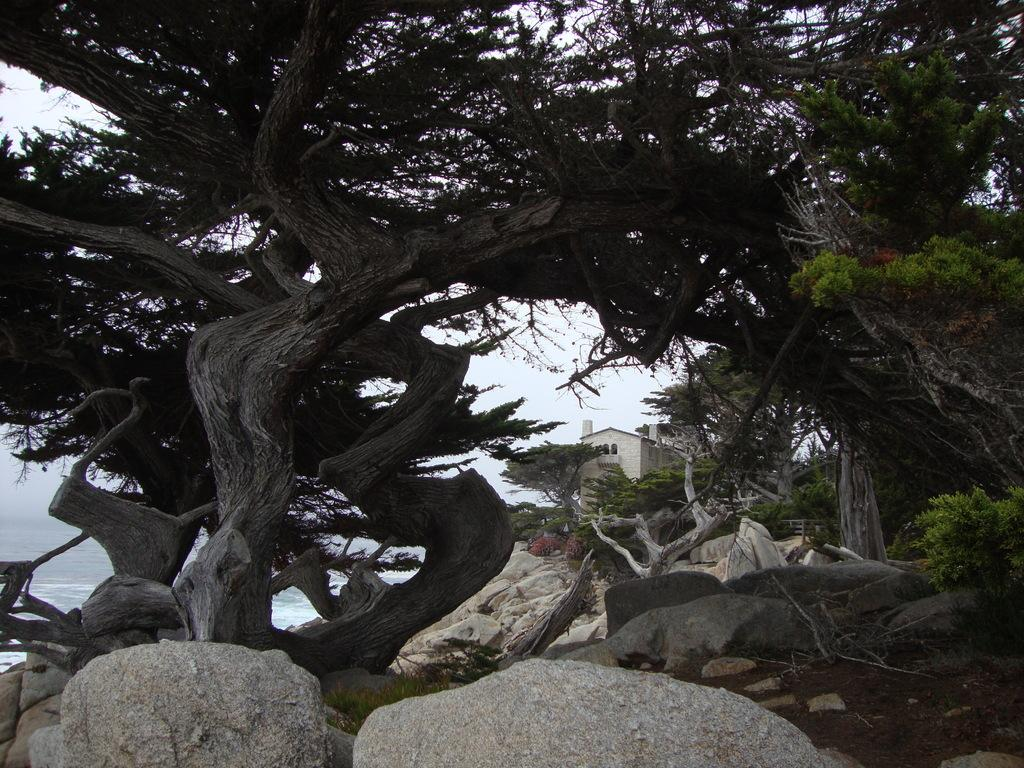What is located in the center of the image? There are trees in the center of the image. What type of structures can be seen in the image? There are buildings in the image. What is present at the bottom of the image? There are rocks, plants, and stones at the bottom of the image. What can be seen in the background of the image? There is a beach and the sky visible in the background of the image. What activity is the pocket participating in within the image? There is no pocket present in the image, so it cannot participate in any activity. Can you describe the cannon's role in the image? There is no cannon present in the image, so it does not have a role. 